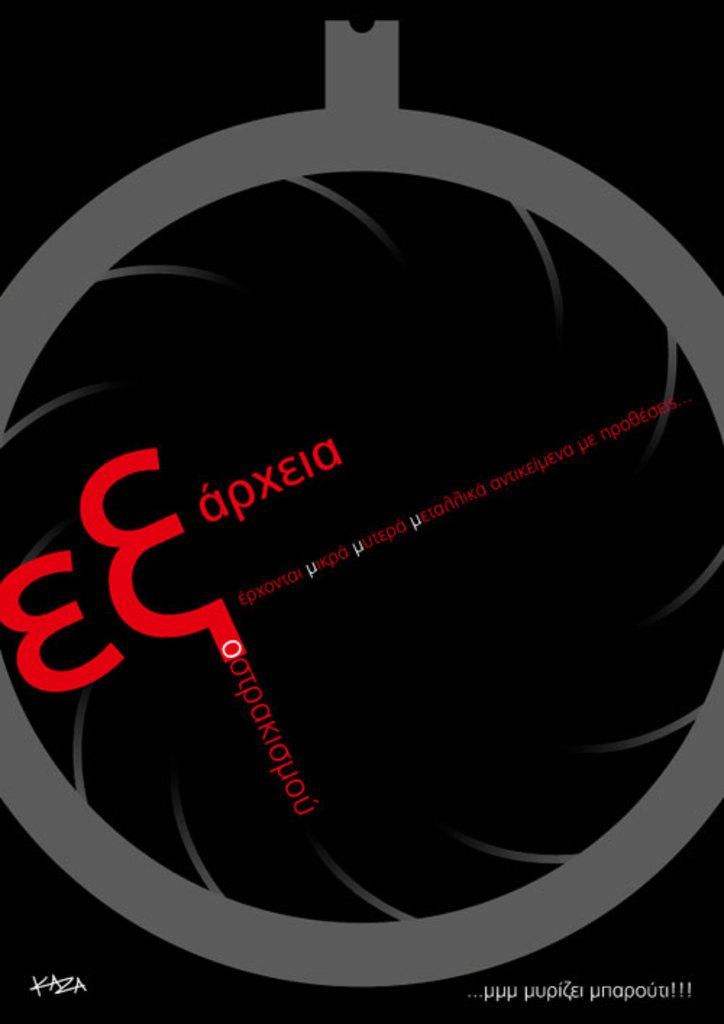What is the name of the brand?
Provide a short and direct response. Unanswerable. 